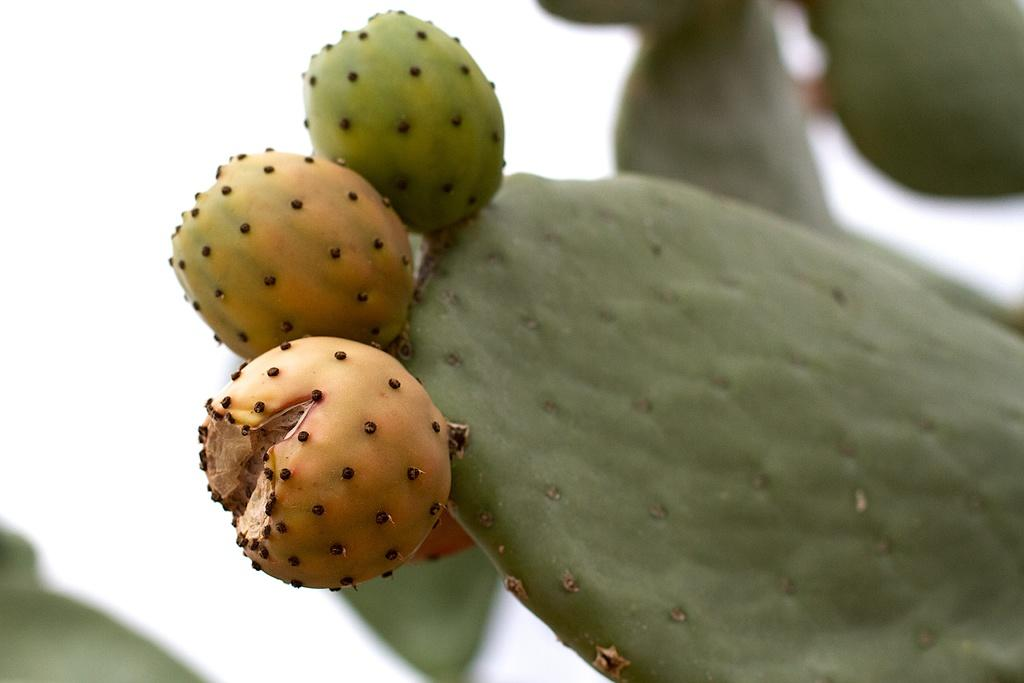What is the main color of the object in the image? The object in the image has a green color. Can you describe the background of the image? The background of the image is blurred. Is there a crown made of gold on top of the green object in the image? There is no crown or any other object visible on top of the green object in the image. 